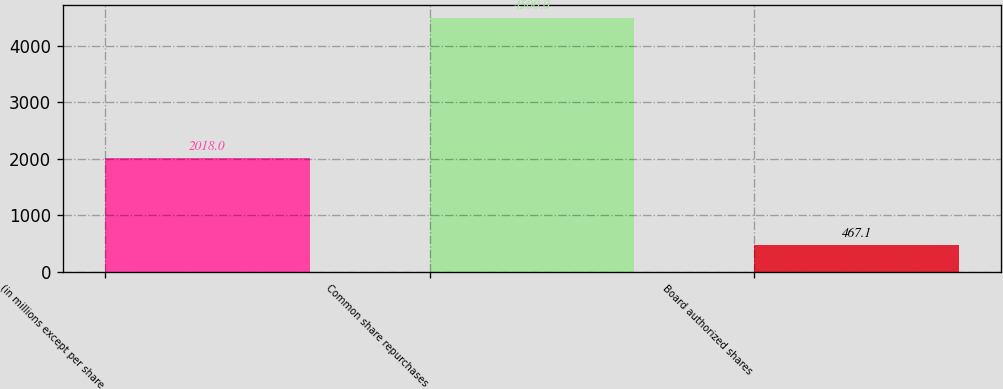Convert chart. <chart><loc_0><loc_0><loc_500><loc_500><bar_chart><fcel>(in millions except per share<fcel>Common share repurchases<fcel>Board authorized shares<nl><fcel>2018<fcel>4500<fcel>467.1<nl></chart> 